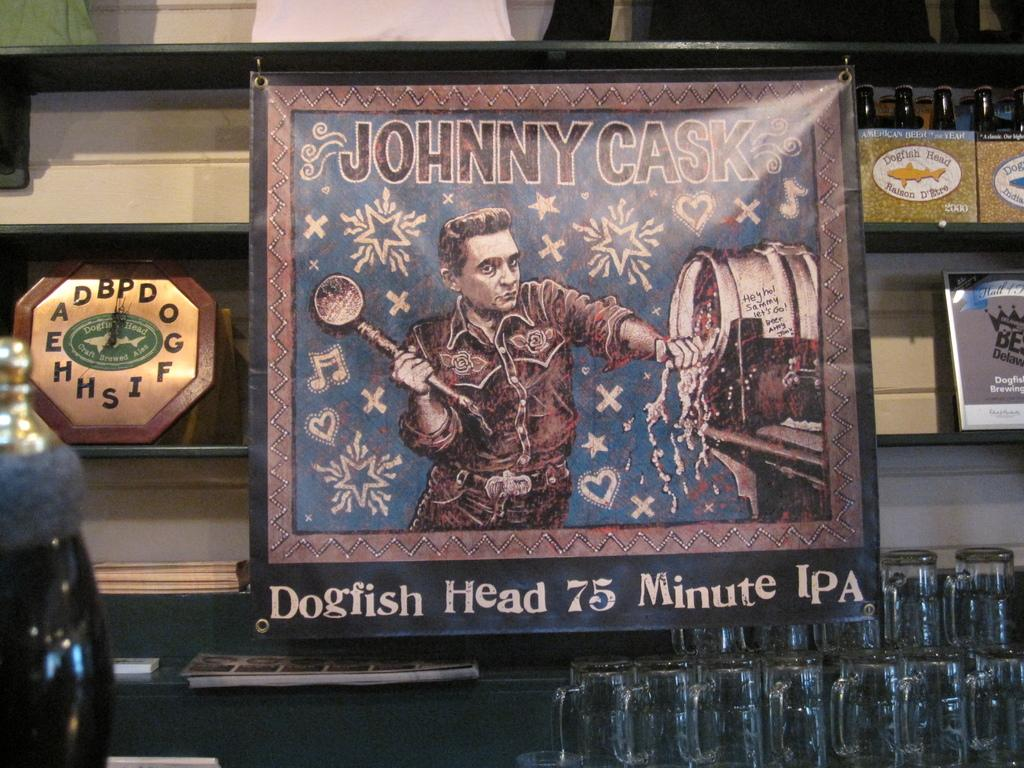<image>
Render a clear and concise summary of the photo. An advertisement for Dogfish Head 75 minute ipa 